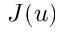<formula> <loc_0><loc_0><loc_500><loc_500>J ( u )</formula> 